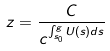<formula> <loc_0><loc_0><loc_500><loc_500>z = \frac { C } { c ^ { \int _ { s _ { 0 } } ^ { g } U ( s ) d s } }</formula> 